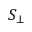<formula> <loc_0><loc_0><loc_500><loc_500>S _ { \bot }</formula> 